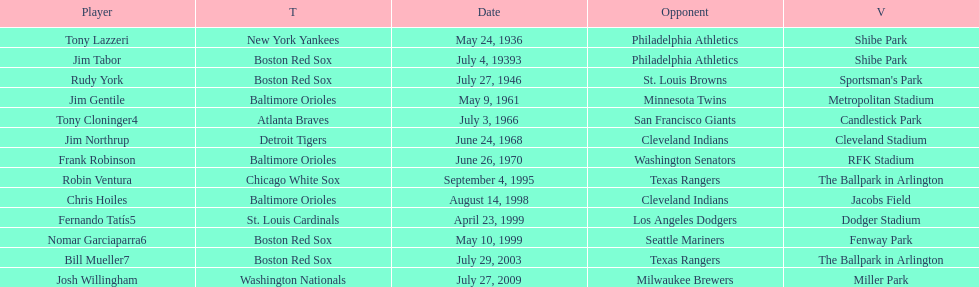What was the name of the last person to accomplish this up to date? Josh Willingham. 